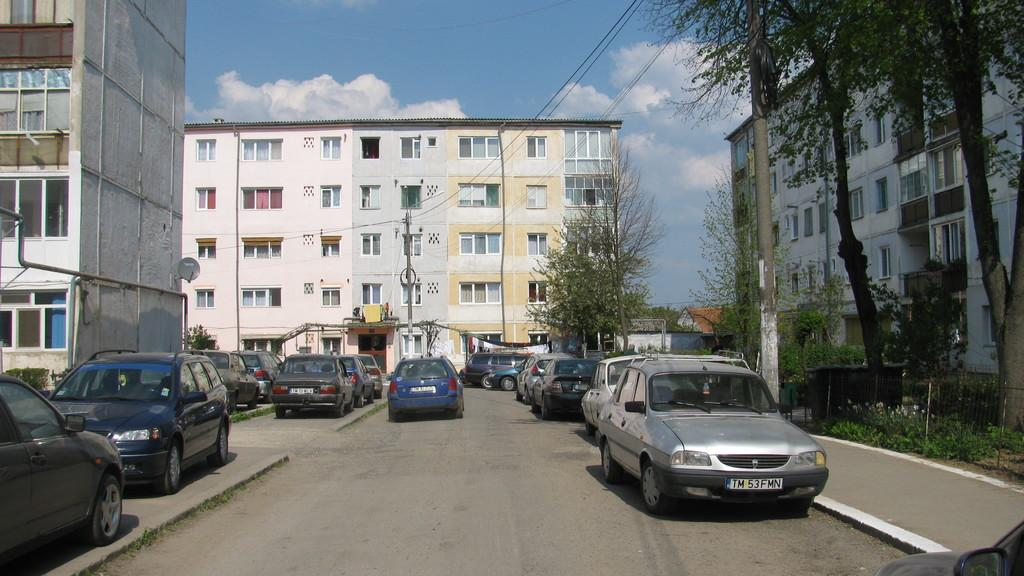What type of structures can be seen in the image? There are buildings in the image. What else can be seen in the image besides buildings? There are poles with wires, vehicles on the road, plants, and other objects on the ground in the image. What is visible in the background of the image? The sky is visible in the background of the image. What type of skin is visible on the hand in the image? There is no hand or skin present in the image. What type of food is being cooked in the image? There is no cooking or food preparation visible in the image. 